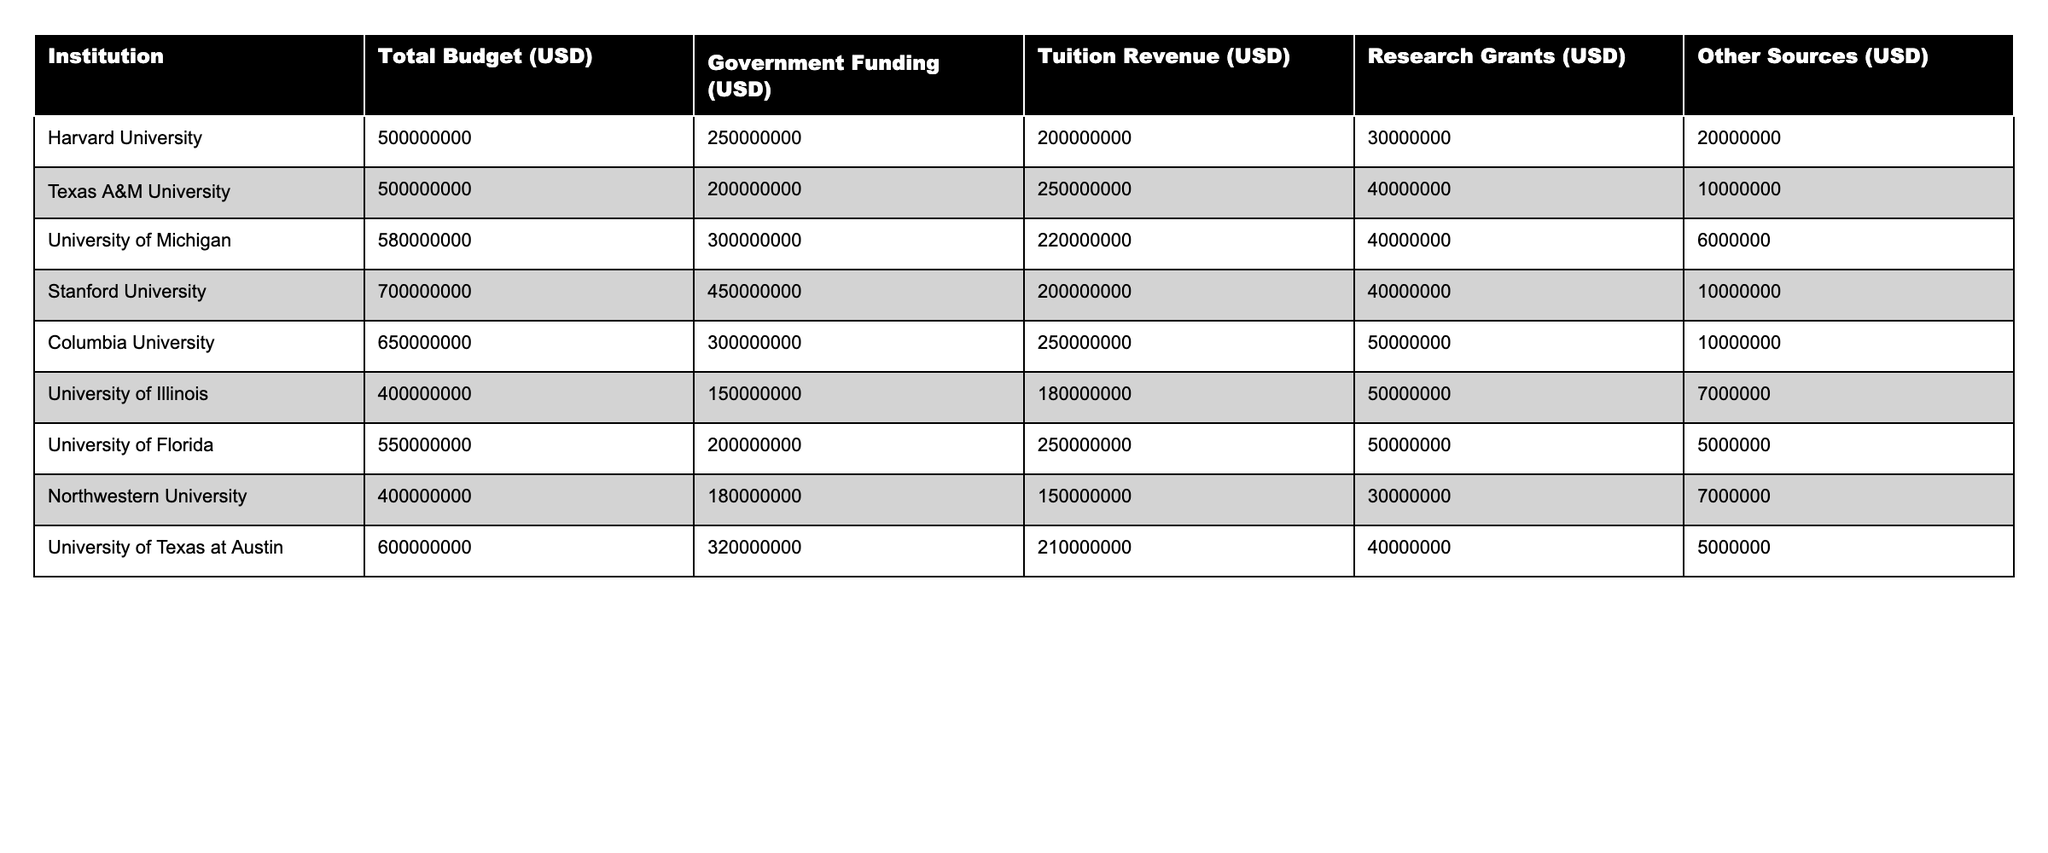What is the total budget for the University of Michigan? The table lists the total budget for the University of Michigan as 580,000,000 USD.
Answer: 580,000,000 USD Which institution received the highest government funding? According to the table, Stanford University received the highest government funding of 450,000,000 USD.
Answer: Stanford University What is the difference in tuition revenue between Harvard University and Northwestern University? The tuition revenue for Harvard University is 200,000,000 USD, and for Northwestern University, it is 150,000,000 USD. The difference is 200,000,000 - 150,000,000 = 50,000,000 USD.
Answer: 50,000,000 USD What is the total amount of research grants received by the top three institutions? The research grants for the top three institutions are as follows: Stanford University (40,000,000 USD), Columbia University (50,000,000 USD), and University of Michigan (40,000,000 USD). Their total is 40,000,000 + 50,000,000 + 40,000,000 = 130,000,000 USD.
Answer: 130,000,000 USD Is the total budget for Texas A&M University greater than the sum of its tuition revenue and research grants? The total budget for Texas A&M University is 500,000,000 USD. The sum of its tuition revenue (250,000,000 USD) and research grants (40,000,000 USD) is 250,000,000 + 40,000,000 = 290,000,000 USD. Since 500,000,000 is greater than 290,000,000, the statement is true.
Answer: Yes What percentage of the total budget for the University of Illinois comes from government funding? The total budget for the University of Illinois is 400,000,000 USD, and government funding is 150,000,000 USD. To calculate the percentage, (150,000,000 / 400,000,000) * 100 = 37.5%.
Answer: 37.5% Which institution has the lowest total budget and what is it? The table shows that the University of Illinois has the lowest total budget of 400,000,000 USD.
Answer: University of Illinois, 400,000,000 USD If we consider only research grants, which institution has the least, and what is the amount? The research grants for Northwestern University are 30,000,000 USD, which is less than those for the other institutions listed.
Answer: Northwestern University, 30,000,000 USD What is the average tuition revenue of all institutions listed? To find the average tuition revenue, sum the tuition revenues: 200,000,000 + 250,000,000 + 220,000,000 + 200,000,000 + 250,000,000 + 180,000,000 + 250,000,000 + 150,000,000 + 210,000,000 = 1,860,000,000 USD. There are 9 institutions, so the average is 1,860,000,000 / 9 = 206,666,667 USD.
Answer: 206,666,667 USD What is the ratio of total budget to government funding for Columbia University? For Columbia University, the total budget is 650,000,000 USD and government funding is 300,000,000 USD. The ratio is 650,000,000 / 300,000,000 = 2.17 (approximately).
Answer: 2.17 